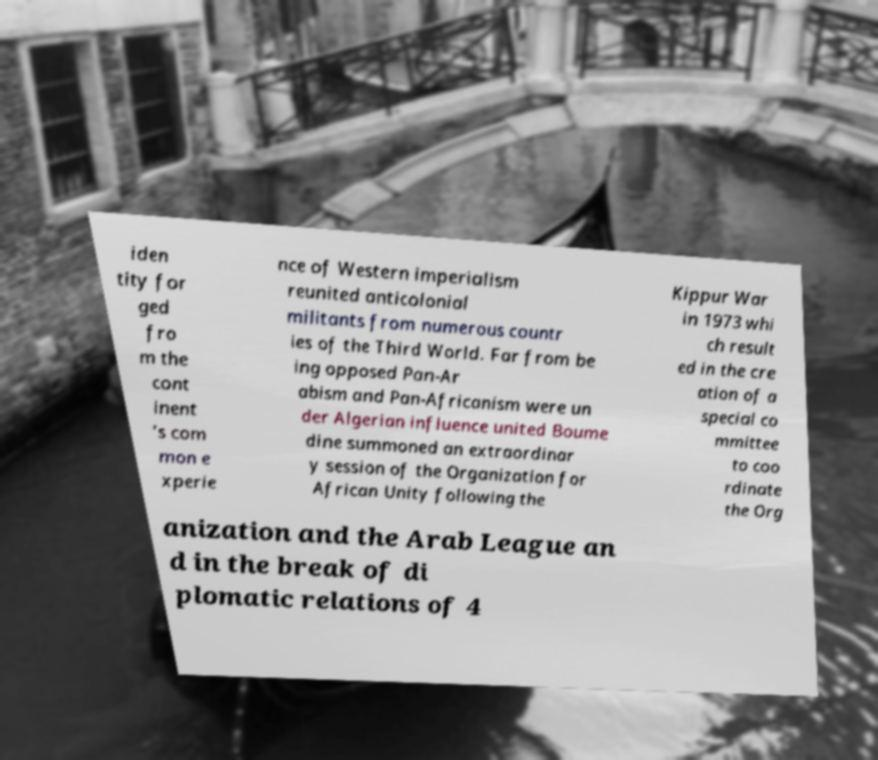Can you read and provide the text displayed in the image?This photo seems to have some interesting text. Can you extract and type it out for me? iden tity for ged fro m the cont inent ’s com mon e xperie nce of Western imperialism reunited anticolonial militants from numerous countr ies of the Third World. Far from be ing opposed Pan-Ar abism and Pan-Africanism were un der Algerian influence united Boume dine summoned an extraordinar y session of the Organization for African Unity following the Kippur War in 1973 whi ch result ed in the cre ation of a special co mmittee to coo rdinate the Org anization and the Arab League an d in the break of di plomatic relations of 4 